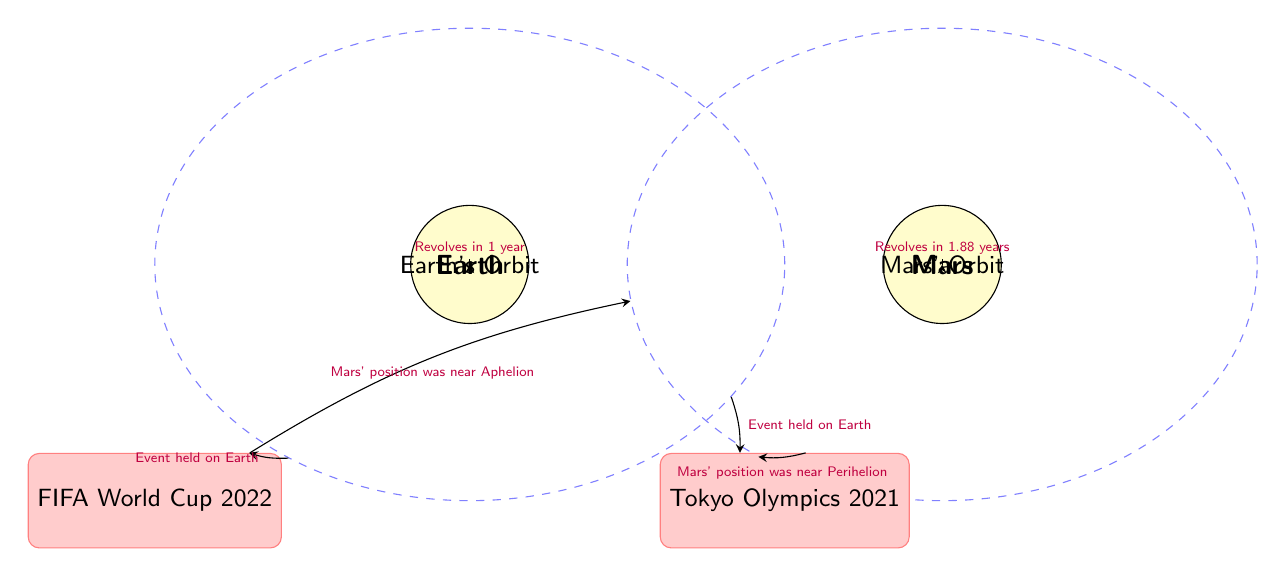What event was held in 2022? The diagram shows the FIFA World Cup 2022 as an event held on Earth. There is a direct connection labeled "Event held on Earth" linking the Earth's orbit to the World Cup event.
Answer: FIFA World Cup 2022 What is Mars' revolution period? The diagram provides information on Mars' orbit which states it revolves in 1.88 years. This is indicated above the Mars node with an arrow and label.
Answer: 1.88 years How many major sports events are mentioned in the diagram? The diagram includes two events: FIFA World Cup 2022 and Tokyo Olympics 2021. By counting the event nodes in the diagram, we find a total of two events.
Answer: 2 At what position was Mars during the FIFA World Cup 2022? The diagram details that Mars' position was near Aphelion during the FIFA World Cup 2022, noted in the connection from the event node to Mars' orbit.
Answer: Aphelion What is Earth's revolution period? The diagram specifies that Earth revolves in 1 year, indicated by the connection labeled "Revolves in 1 year" from the Earth node to Earth's orbit.
Answer: 1 year Which planet is closer to the Sun? Given the diagram's context, Earth is positioned at the center (0,0), while Mars is further (6,0), indicating that Earth is closer to the Sun than Mars.
Answer: Earth What orbit is associated with the Tokyo Olympics 2021? The Tokyo Olympics 2021 event is positioned under the Earth’s orbit. The connection indicates that the event relates to Earth's position, which is referenced in the diagram.
Answer: Earth's Orbit How is Mars' distance from the Sun during the Tokyo Olympics characterized? The diagram describes that Mars' position was near Perihelion during the Tokyo Olympics, indicated by the connection linking the event to Mars' orbit.
Answer: Near Perihelion 